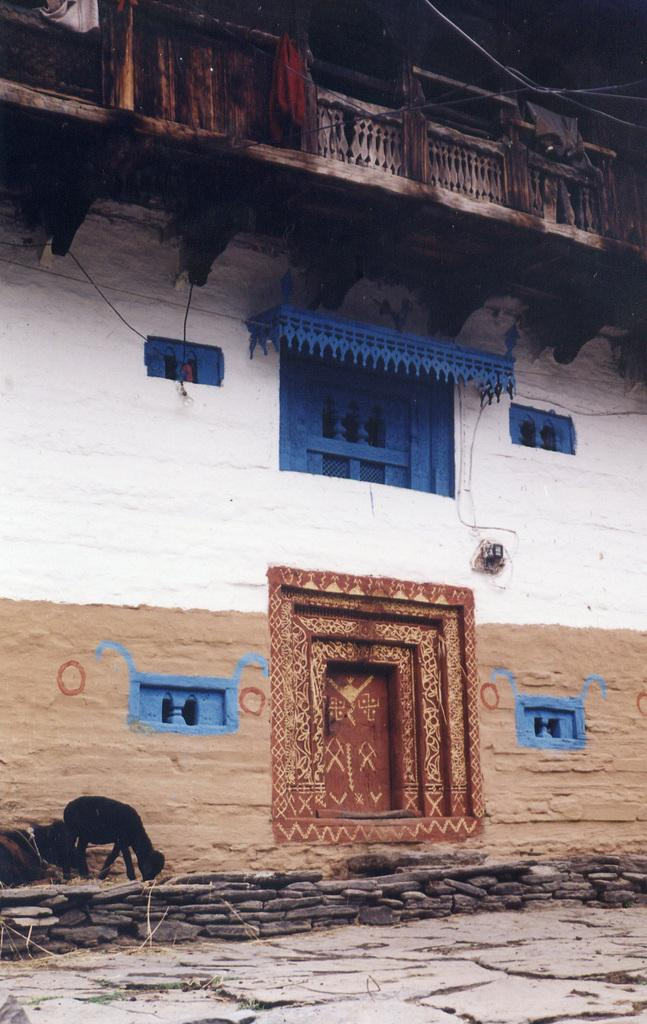What type of structure is visible in the image? There is a building in the image. What features can be seen on the building? The building has a door and windows. What animals are present on the left side of the image? There are goats on the left side of the image. What is at the bottom of the image? There is flooring at the bottom of the image. Can you see any docks in the image? A: There is no dock present in the image. What color is the toe of the person in the image? There is no person present in the image, so we cannot determine the color of their toe. 